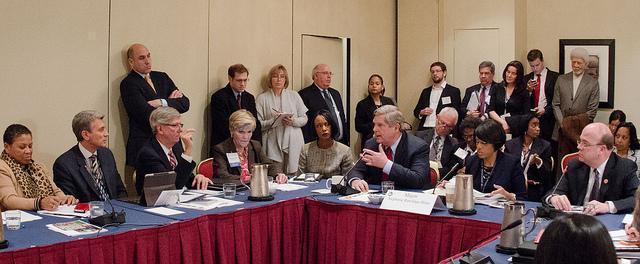How many people are in the picture?
Give a very brief answer. 12. 